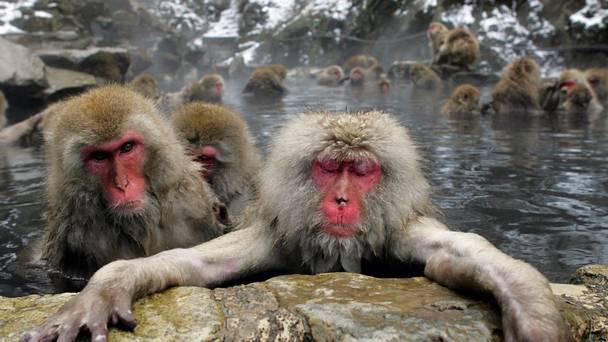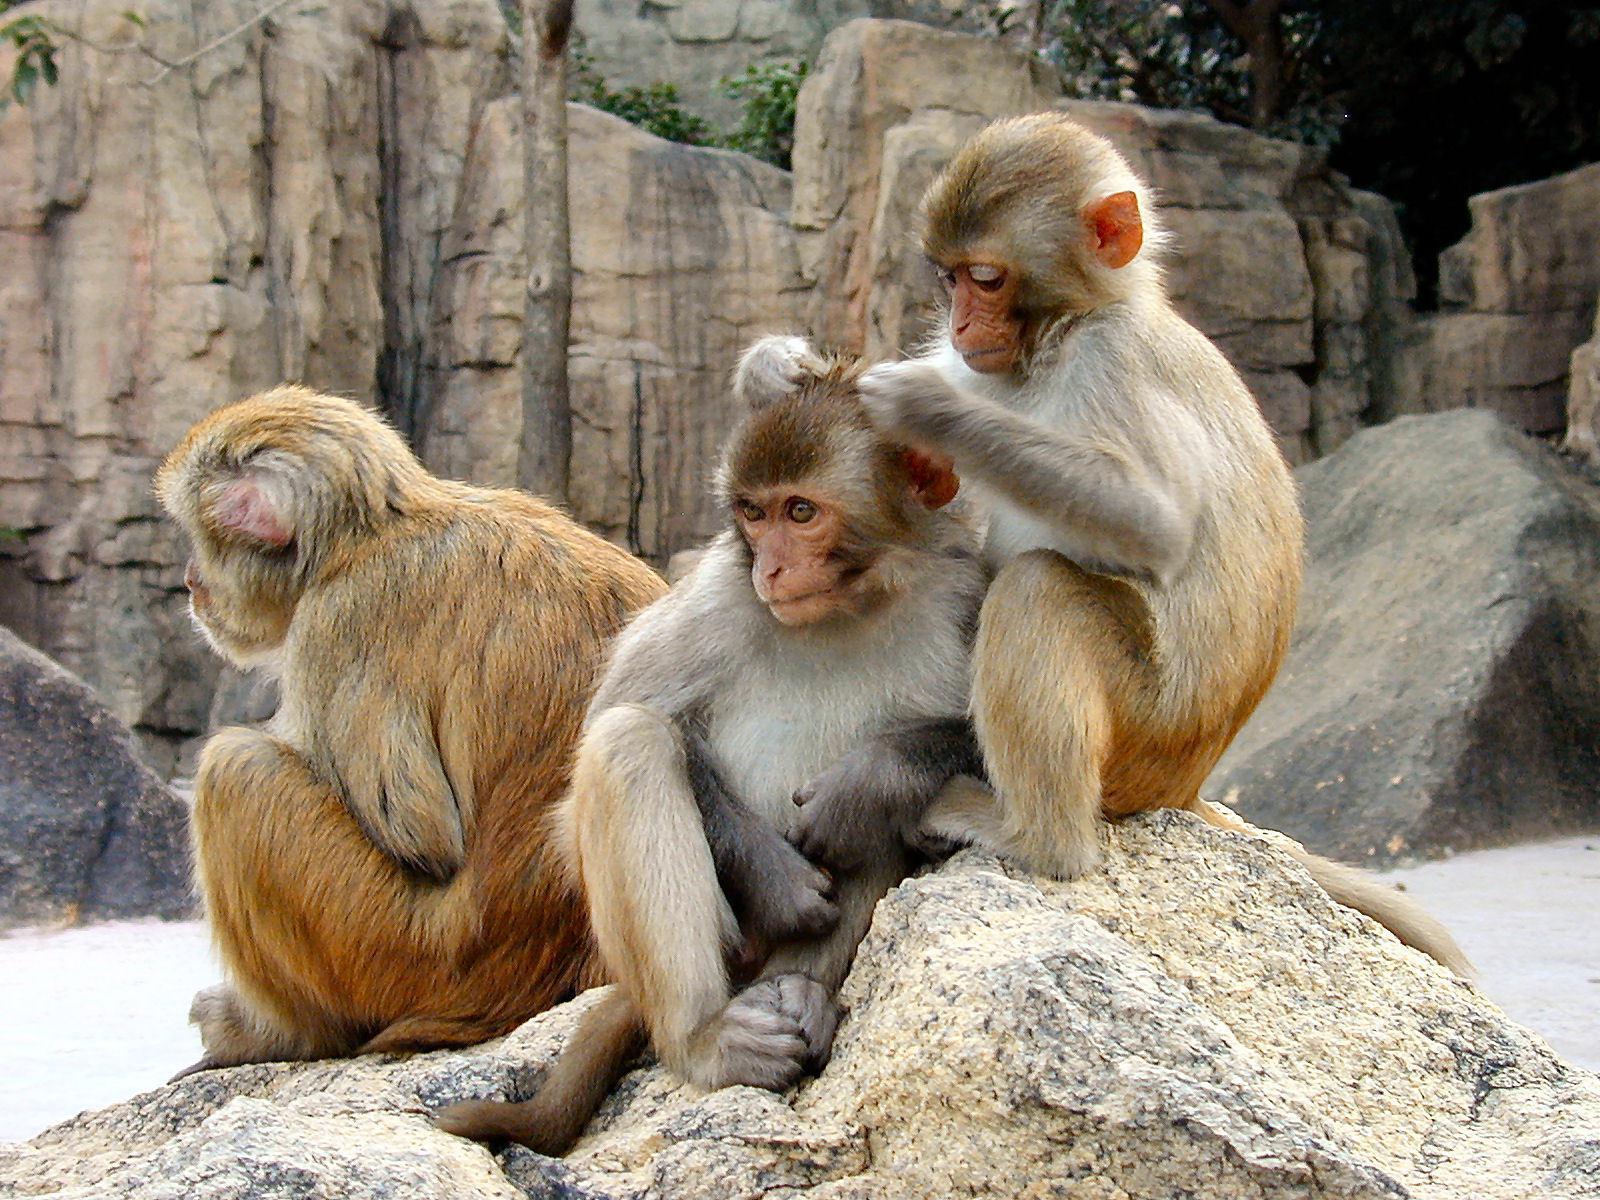The first image is the image on the left, the second image is the image on the right. Considering the images on both sides, is "One image depicts at aleast a dozen baboons posed on a dry surface." valid? Answer yes or no. No. The first image is the image on the left, the second image is the image on the right. Examine the images to the left and right. Is the description "There is a single babboon in one of the images." accurate? Answer yes or no. No. The first image is the image on the left, the second image is the image on the right. Analyze the images presented: Is the assertion "An image shows the bulbous pinkish rear of one adult baboon." valid? Answer yes or no. No. The first image is the image on the left, the second image is the image on the right. Examine the images to the left and right. Is the description "There is exactly one animal in one of the images." accurate? Answer yes or no. No. 